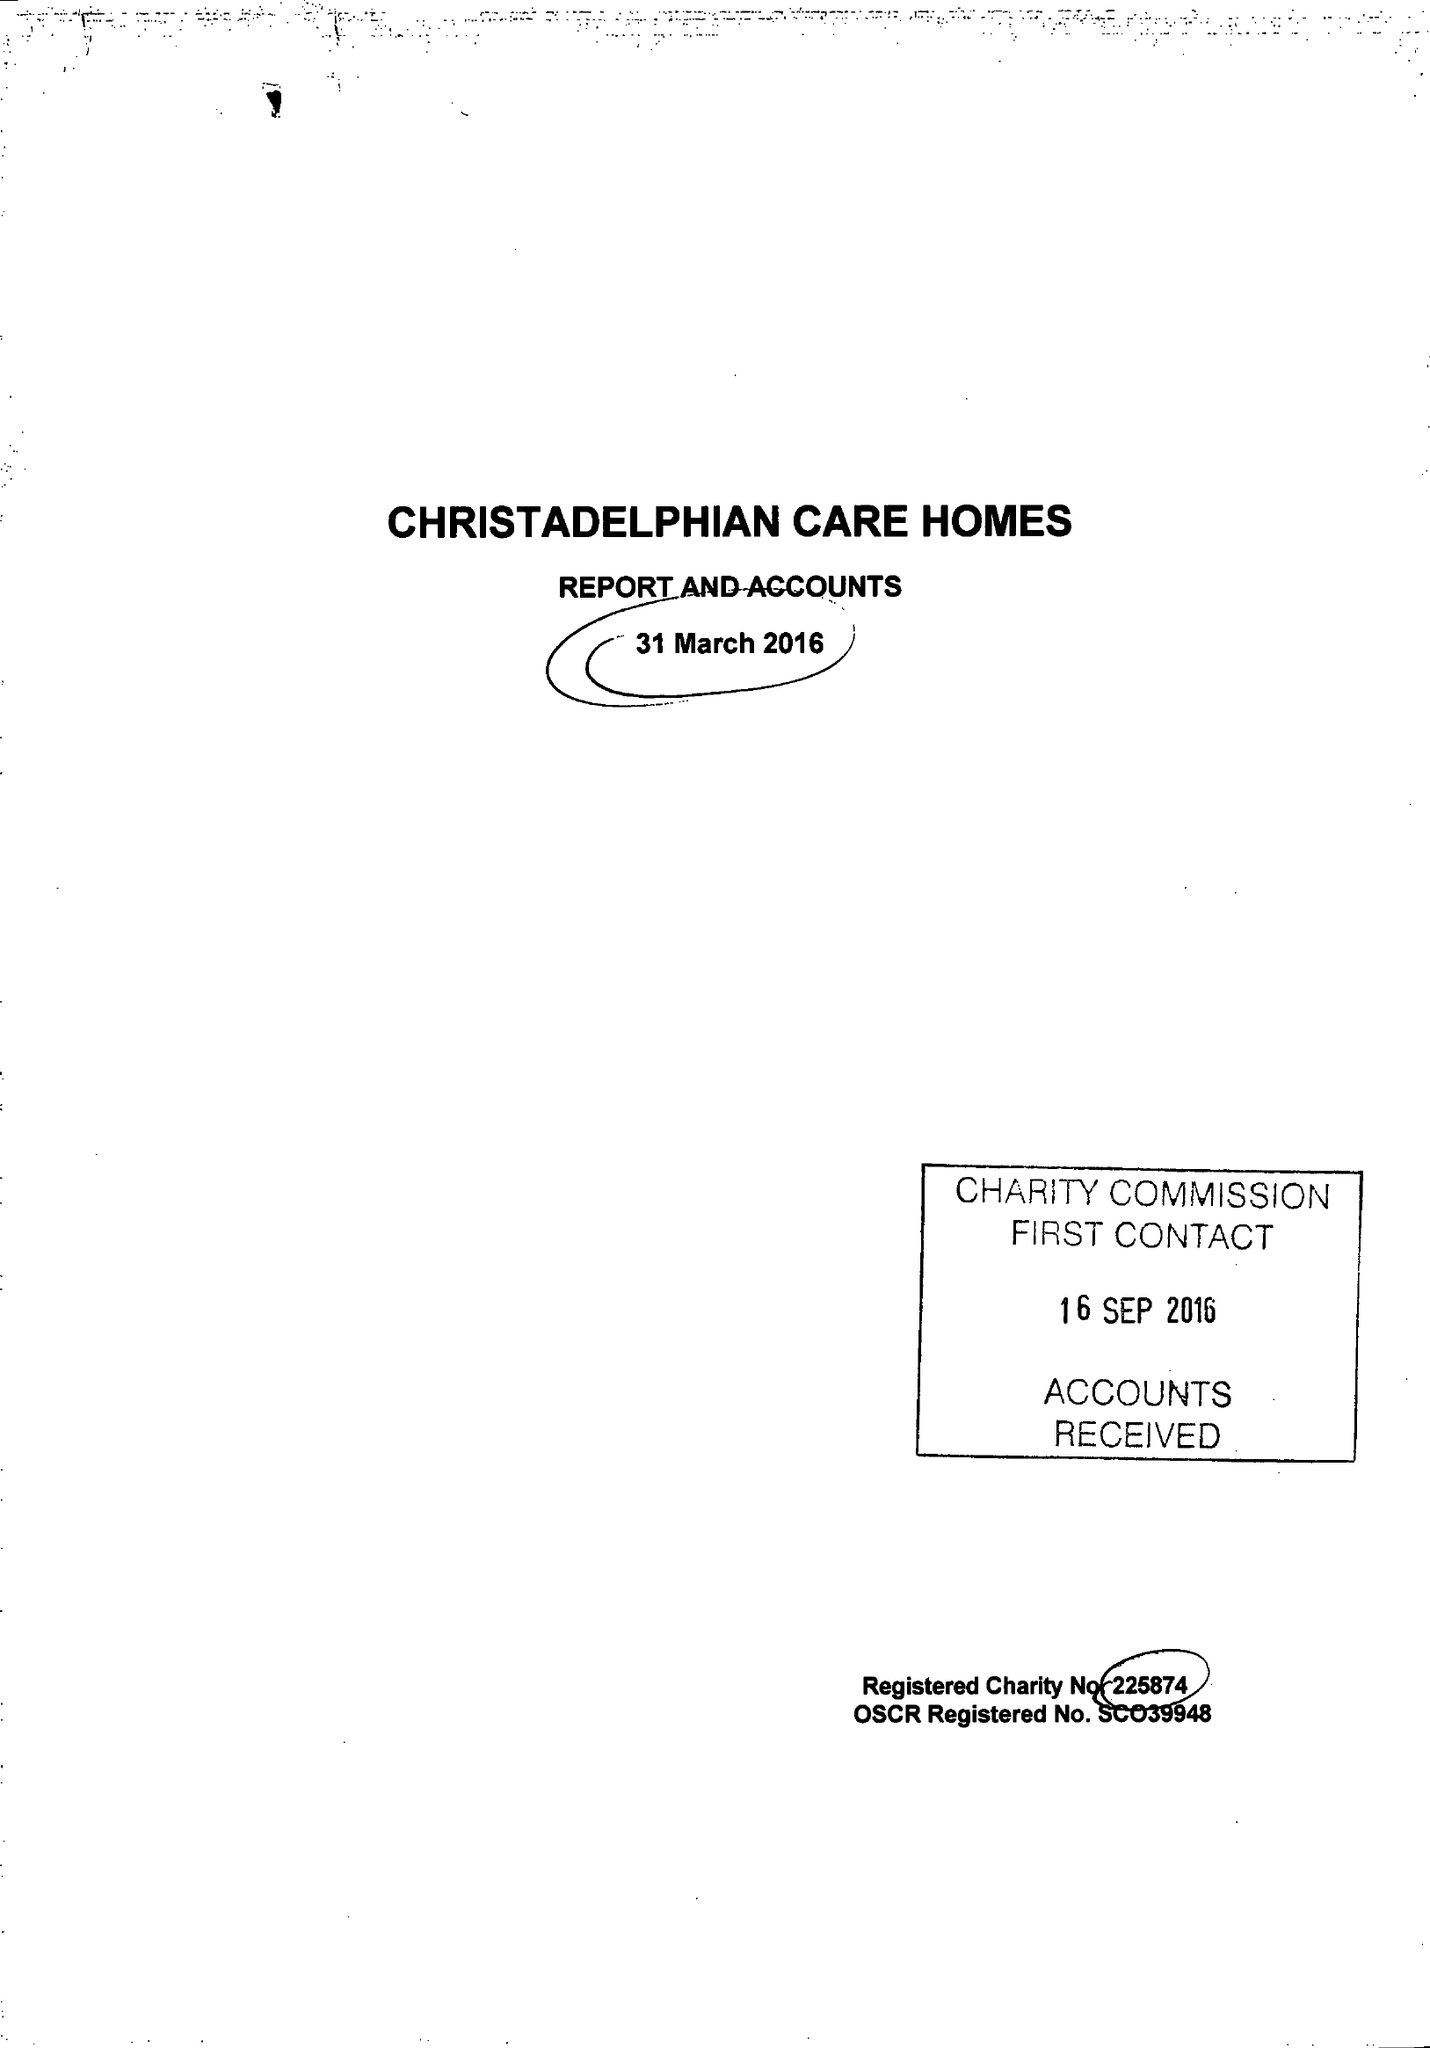What is the value for the address__street_line?
Answer the question using a single word or phrase. 17 SHERBOURNE ROAD 